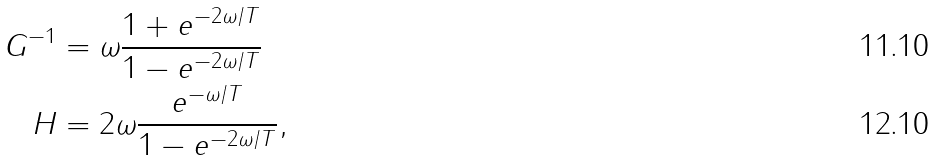<formula> <loc_0><loc_0><loc_500><loc_500>G ^ { - 1 } & = \omega \frac { 1 + e ^ { - 2 \omega / T } } { 1 - e ^ { - 2 \omega / T } } \\ H & = 2 \omega \frac { e ^ { - \omega / T } } { 1 - e ^ { - 2 \omega / T } } ,</formula> 